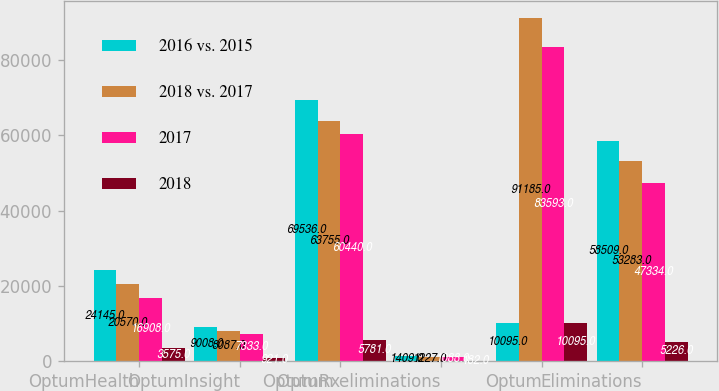Convert chart. <chart><loc_0><loc_0><loc_500><loc_500><stacked_bar_chart><ecel><fcel>OptumHealth<fcel>OptumInsight<fcel>OptumRx<fcel>Optum eliminations<fcel>Optum<fcel>Eliminations<nl><fcel>2016 vs. 2015<fcel>24145<fcel>9008<fcel>69536<fcel>1409<fcel>10095<fcel>58509<nl><fcel>2018 vs. 2017<fcel>20570<fcel>8087<fcel>63755<fcel>1227<fcel>91185<fcel>53283<nl><fcel>2017<fcel>16908<fcel>7333<fcel>60440<fcel>1088<fcel>83593<fcel>47334<nl><fcel>2018<fcel>3575<fcel>921<fcel>5781<fcel>182<fcel>10095<fcel>5226<nl></chart> 